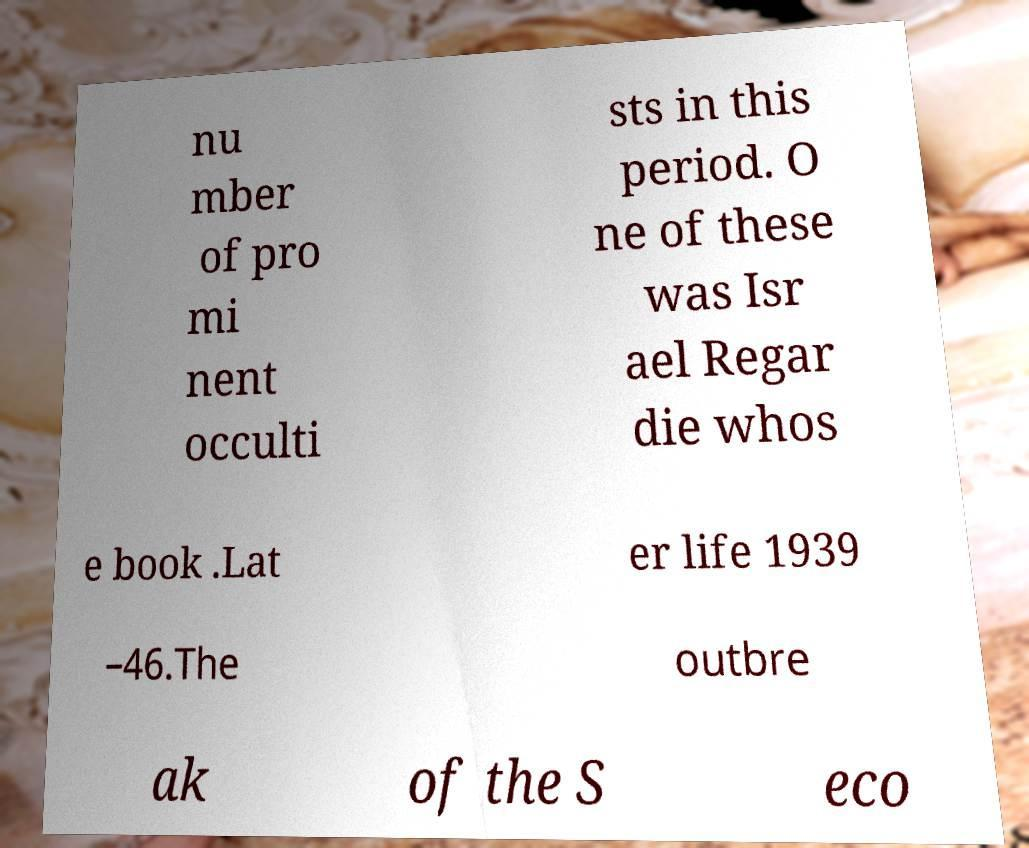What messages or text are displayed in this image? I need them in a readable, typed format. nu mber of pro mi nent occulti sts in this period. O ne of these was Isr ael Regar die whos e book .Lat er life 1939 –46.The outbre ak of the S eco 